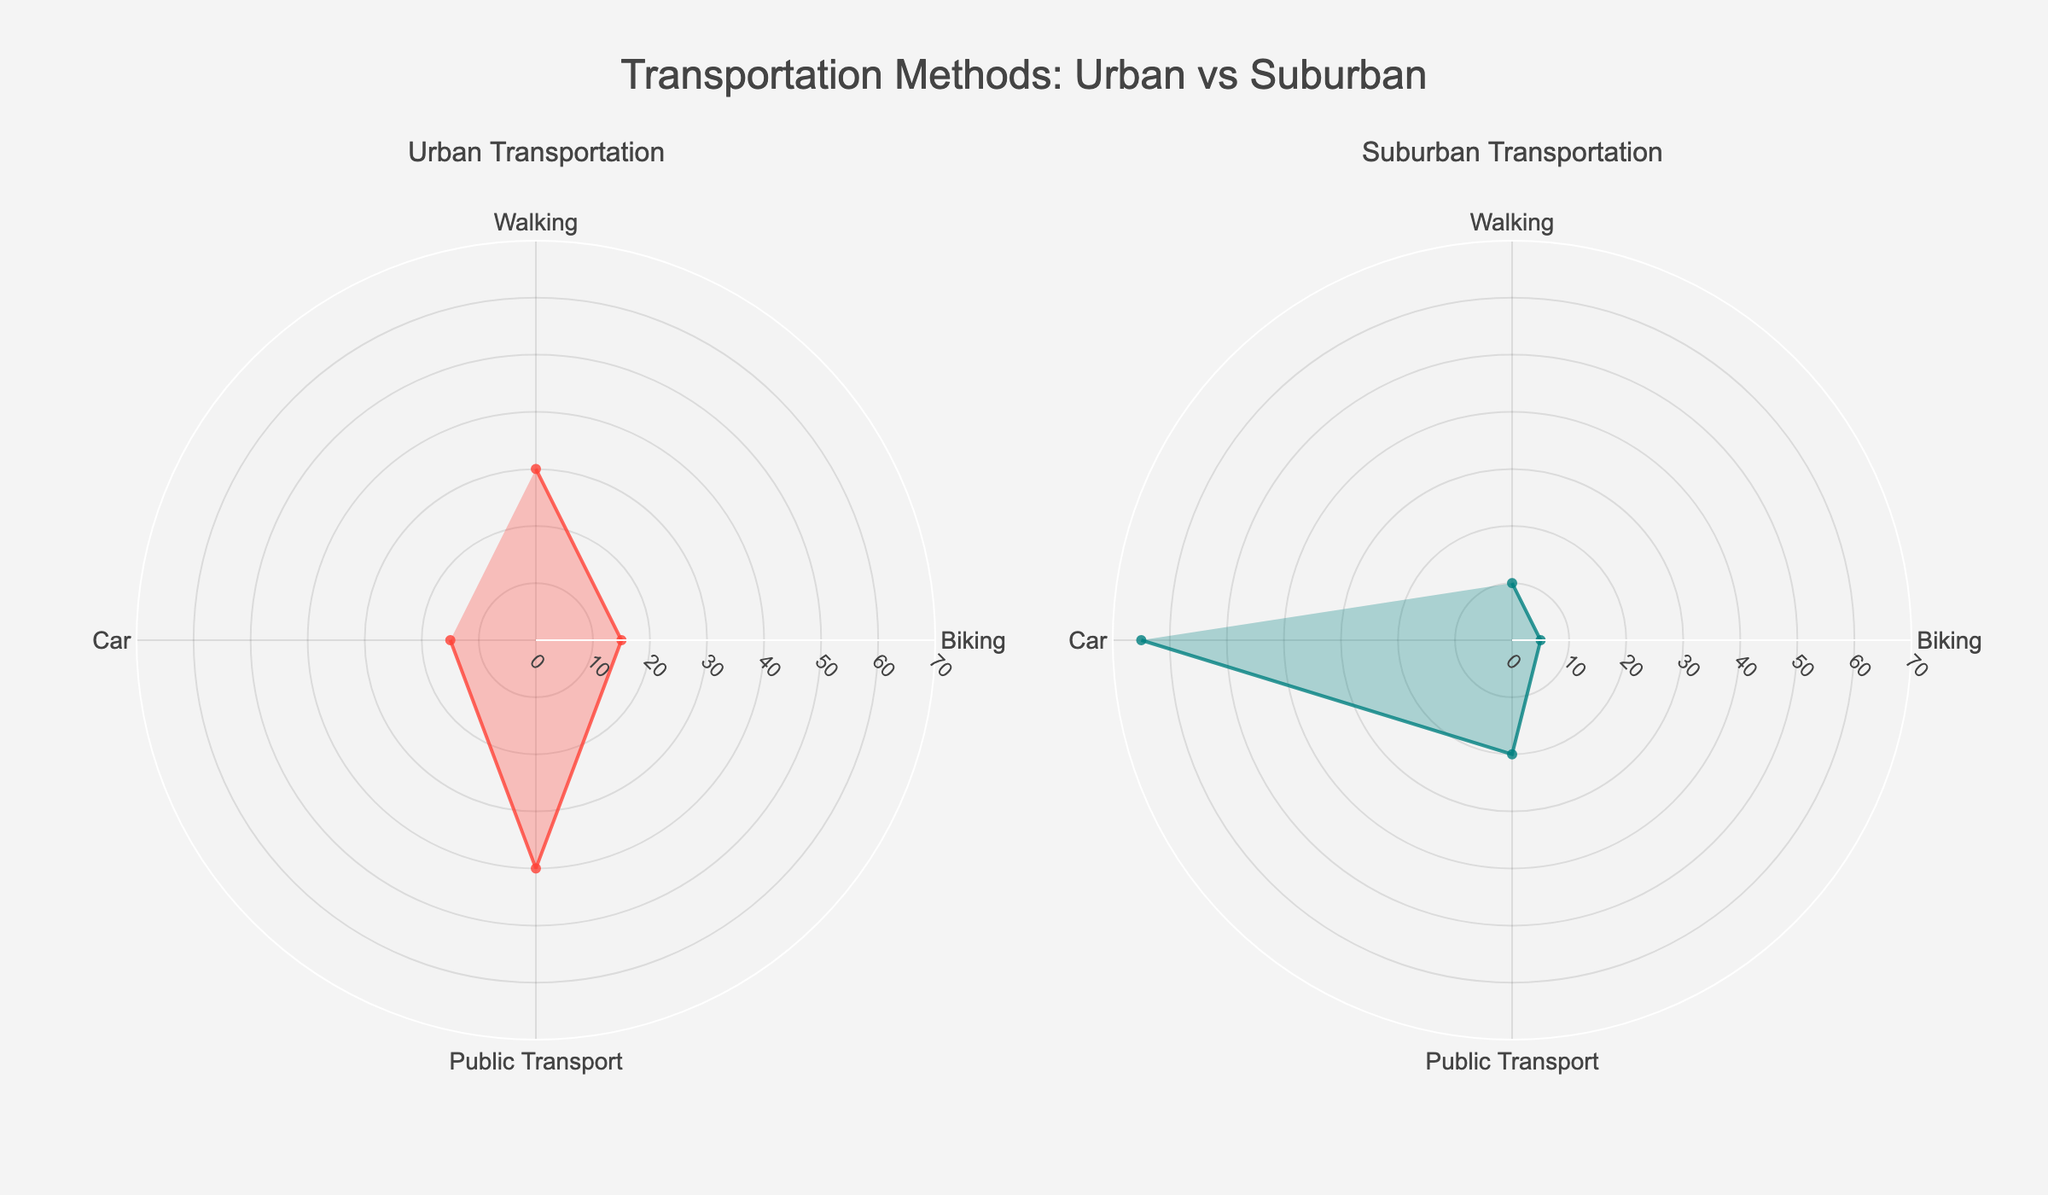What is the title of the figure? The title of the figure is prominently displayed at the top of the plot and states, "Transportation Methods: Urban vs Suburban".
Answer: Transportation Methods: Urban vs Suburban Which transportation method has the highest usage percentage in urban areas? By looking at the radar chart for Urban Transportation, the transportation method with the highest usage is Public Transport, which is marked at 40%.
Answer: Public Transport Which transportation method has the lowest usage percentage in suburban areas? Observing the radar chart for Suburban Transportation, biking has the lowest usage percentage at 5%.
Answer: Biking What is the difference in walking usage between urban and suburban areas? In the radar charts, walking usage in urban areas is 30%, while in suburban areas it is 10%. The difference is 30% - 10% = 20%.
Answer: 20% Which area has a higher percentage of car usage, and by how much? From the radar charts, suburban car usage is at 65%, and urban car usage is at 15%. The suburban car usage is higher by 65% - 15% = 50%.
Answer: Suburban; 50% What is the combined percentage of biking and public transport usage in urban areas? In the Urban Transportation radar chart, biking usage is 15% and public transport usage is 40%. Combined, they sum up to 15% + 40% = 55%.
Answer: 55% What percentage of people use public transport in suburban areas? Looking at the radar chart for Suburban Transportation, the usage percentage for public transport is 20%.
Answer: 20% Compare the usage of walking in urban and suburban areas. Which has a higher percentage and what might that indicate about lifestyle differences? Urban areas have a higher percentage of walking (30%) compared to suburban areas (10%). This suggests that urban residents might have closer amenities and better pedestrian infrastructure compared to suburban areas.
Answer: Urban; indicates closer amenities and pedestrian-friendly infrastructure What is the average percentage usage of all transport methods in urban areas? Summing up the urban percentages (Walking: 30%, Biking: 15%, Public Transport: 40%, Car: 15%) gives 30% + 15% + 40% + 15% = 100%. The average is 100% / 4 = 25%.
Answer: 25% How does the overall usage of sustainable transportation methods (walking, biking, public transport) compare between urban and suburban areas? In urban areas, sustainable transport usage is (30% walking + 15% biking + 40% public transport) = 85%. In suburban areas, it is (10% walking + 5% biking + 20% public transport) = 35%. Urban areas have significantly higher usage of sustainable transportation methods.
Answer: Urban: 85%; Suburban: 35% 